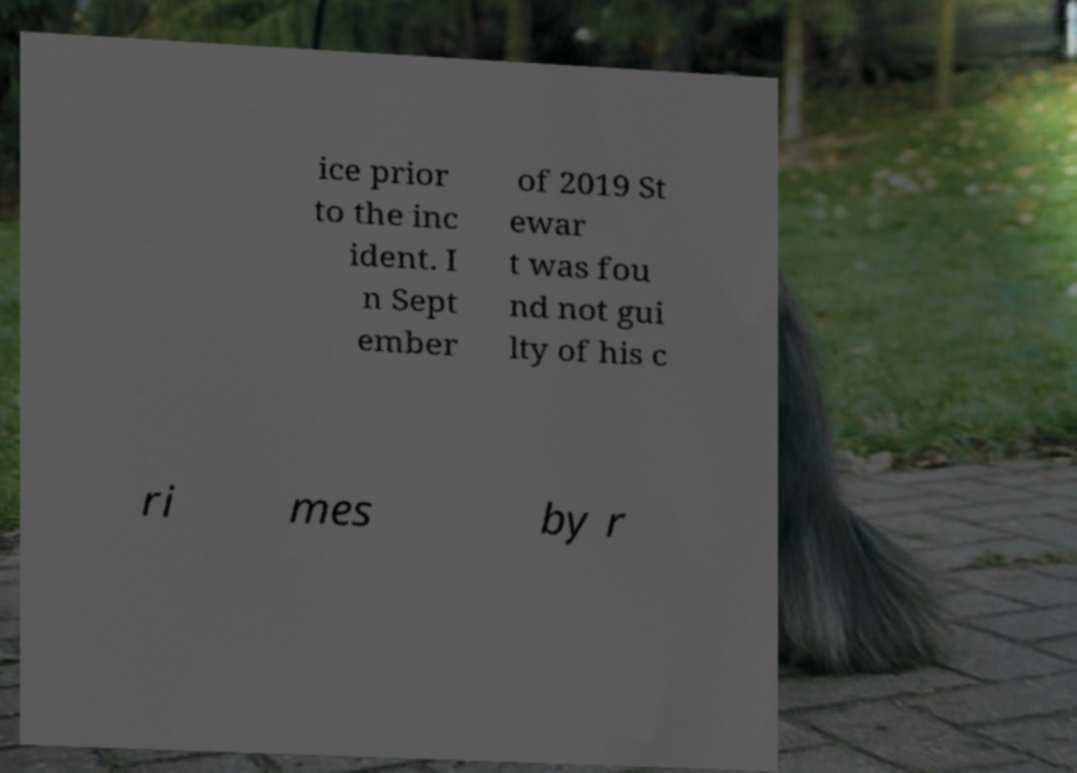Please identify and transcribe the text found in this image. ice prior to the inc ident. I n Sept ember of 2019 St ewar t was fou nd not gui lty of his c ri mes by r 